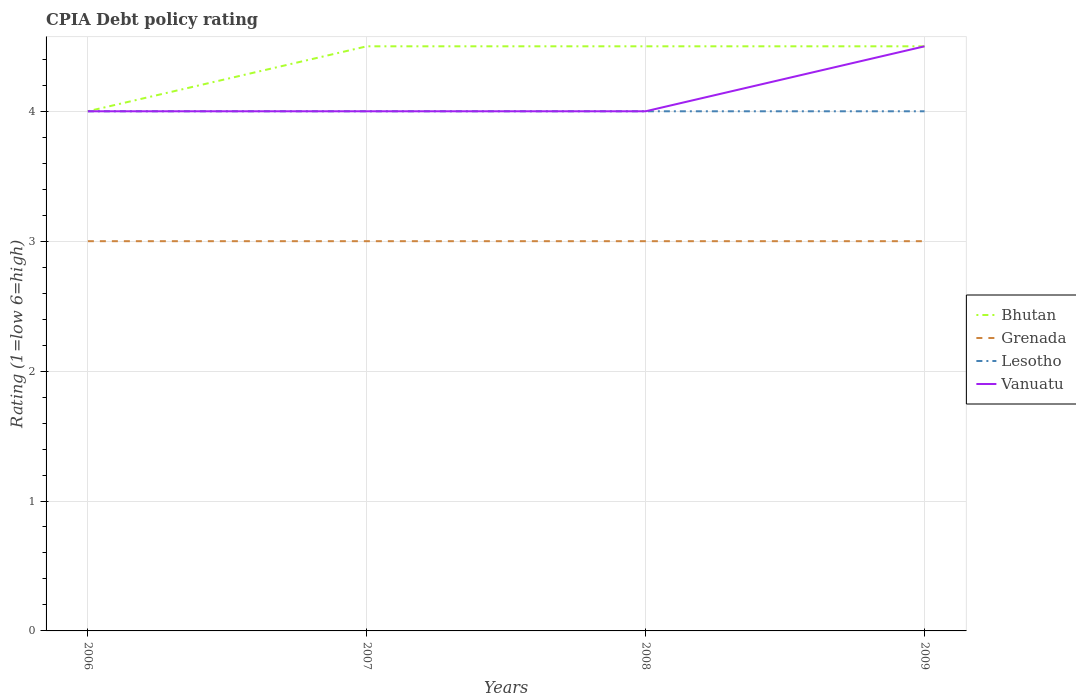How many different coloured lines are there?
Provide a short and direct response. 4. Across all years, what is the maximum CPIA rating in Lesotho?
Make the answer very short. 4. What is the total CPIA rating in Bhutan in the graph?
Your response must be concise. -0.5. What is the difference between the highest and the second highest CPIA rating in Lesotho?
Your response must be concise. 0. What is the difference between the highest and the lowest CPIA rating in Vanuatu?
Make the answer very short. 1. How many lines are there?
Provide a succinct answer. 4. How many years are there in the graph?
Give a very brief answer. 4. What is the difference between two consecutive major ticks on the Y-axis?
Your answer should be very brief. 1. Are the values on the major ticks of Y-axis written in scientific E-notation?
Your answer should be compact. No. Where does the legend appear in the graph?
Provide a succinct answer. Center right. How many legend labels are there?
Make the answer very short. 4. How are the legend labels stacked?
Make the answer very short. Vertical. What is the title of the graph?
Make the answer very short. CPIA Debt policy rating. Does "European Union" appear as one of the legend labels in the graph?
Your answer should be compact. No. What is the label or title of the Y-axis?
Offer a very short reply. Rating (1=low 6=high). What is the Rating (1=low 6=high) in Bhutan in 2006?
Your answer should be compact. 4. What is the Rating (1=low 6=high) of Grenada in 2007?
Ensure brevity in your answer.  3. What is the Rating (1=low 6=high) in Lesotho in 2007?
Give a very brief answer. 4. What is the Rating (1=low 6=high) in Vanuatu in 2007?
Offer a very short reply. 4. What is the Rating (1=low 6=high) of Bhutan in 2008?
Your answer should be compact. 4.5. What is the Rating (1=low 6=high) of Lesotho in 2008?
Your answer should be compact. 4. What is the Rating (1=low 6=high) in Vanuatu in 2008?
Ensure brevity in your answer.  4. What is the Rating (1=low 6=high) in Bhutan in 2009?
Offer a terse response. 4.5. What is the Rating (1=low 6=high) of Grenada in 2009?
Provide a succinct answer. 3. What is the Rating (1=low 6=high) of Lesotho in 2009?
Offer a very short reply. 4. What is the Rating (1=low 6=high) of Vanuatu in 2009?
Ensure brevity in your answer.  4.5. Across all years, what is the maximum Rating (1=low 6=high) of Lesotho?
Your answer should be very brief. 4. Across all years, what is the minimum Rating (1=low 6=high) in Bhutan?
Your response must be concise. 4. Across all years, what is the minimum Rating (1=low 6=high) of Grenada?
Your answer should be compact. 3. Across all years, what is the minimum Rating (1=low 6=high) in Vanuatu?
Your answer should be very brief. 4. What is the total Rating (1=low 6=high) of Bhutan in the graph?
Provide a short and direct response. 17.5. What is the total Rating (1=low 6=high) in Vanuatu in the graph?
Your answer should be compact. 16.5. What is the difference between the Rating (1=low 6=high) of Bhutan in 2006 and that in 2008?
Ensure brevity in your answer.  -0.5. What is the difference between the Rating (1=low 6=high) in Grenada in 2006 and that in 2008?
Make the answer very short. 0. What is the difference between the Rating (1=low 6=high) of Bhutan in 2006 and that in 2009?
Offer a very short reply. -0.5. What is the difference between the Rating (1=low 6=high) in Grenada in 2006 and that in 2009?
Give a very brief answer. 0. What is the difference between the Rating (1=low 6=high) in Vanuatu in 2006 and that in 2009?
Offer a terse response. -0.5. What is the difference between the Rating (1=low 6=high) in Bhutan in 2007 and that in 2008?
Offer a very short reply. 0. What is the difference between the Rating (1=low 6=high) of Grenada in 2007 and that in 2008?
Make the answer very short. 0. What is the difference between the Rating (1=low 6=high) of Lesotho in 2007 and that in 2008?
Your answer should be compact. 0. What is the difference between the Rating (1=low 6=high) in Grenada in 2008 and that in 2009?
Provide a short and direct response. 0. What is the difference between the Rating (1=low 6=high) of Lesotho in 2008 and that in 2009?
Provide a short and direct response. 0. What is the difference between the Rating (1=low 6=high) in Vanuatu in 2008 and that in 2009?
Your answer should be very brief. -0.5. What is the difference between the Rating (1=low 6=high) in Bhutan in 2006 and the Rating (1=low 6=high) in Grenada in 2007?
Provide a short and direct response. 1. What is the difference between the Rating (1=low 6=high) of Grenada in 2006 and the Rating (1=low 6=high) of Lesotho in 2007?
Provide a short and direct response. -1. What is the difference between the Rating (1=low 6=high) in Bhutan in 2006 and the Rating (1=low 6=high) in Lesotho in 2008?
Provide a short and direct response. 0. What is the difference between the Rating (1=low 6=high) in Bhutan in 2006 and the Rating (1=low 6=high) in Vanuatu in 2008?
Your answer should be very brief. 0. What is the difference between the Rating (1=low 6=high) in Grenada in 2006 and the Rating (1=low 6=high) in Lesotho in 2008?
Offer a terse response. -1. What is the difference between the Rating (1=low 6=high) in Grenada in 2006 and the Rating (1=low 6=high) in Vanuatu in 2008?
Your answer should be compact. -1. What is the difference between the Rating (1=low 6=high) in Lesotho in 2006 and the Rating (1=low 6=high) in Vanuatu in 2008?
Your response must be concise. 0. What is the difference between the Rating (1=low 6=high) of Bhutan in 2006 and the Rating (1=low 6=high) of Vanuatu in 2009?
Your answer should be very brief. -0.5. What is the difference between the Rating (1=low 6=high) in Grenada in 2006 and the Rating (1=low 6=high) in Vanuatu in 2009?
Your response must be concise. -1.5. What is the difference between the Rating (1=low 6=high) in Lesotho in 2006 and the Rating (1=low 6=high) in Vanuatu in 2009?
Offer a terse response. -0.5. What is the difference between the Rating (1=low 6=high) in Bhutan in 2007 and the Rating (1=low 6=high) in Lesotho in 2008?
Provide a short and direct response. 0.5. What is the difference between the Rating (1=low 6=high) of Grenada in 2007 and the Rating (1=low 6=high) of Vanuatu in 2008?
Give a very brief answer. -1. What is the difference between the Rating (1=low 6=high) in Lesotho in 2007 and the Rating (1=low 6=high) in Vanuatu in 2008?
Give a very brief answer. 0. What is the difference between the Rating (1=low 6=high) of Bhutan in 2007 and the Rating (1=low 6=high) of Grenada in 2009?
Provide a succinct answer. 1.5. What is the difference between the Rating (1=low 6=high) in Bhutan in 2007 and the Rating (1=low 6=high) in Vanuatu in 2009?
Offer a terse response. 0. What is the difference between the Rating (1=low 6=high) in Grenada in 2007 and the Rating (1=low 6=high) in Lesotho in 2009?
Your answer should be compact. -1. What is the difference between the Rating (1=low 6=high) of Grenada in 2007 and the Rating (1=low 6=high) of Vanuatu in 2009?
Keep it short and to the point. -1.5. What is the difference between the Rating (1=low 6=high) in Bhutan in 2008 and the Rating (1=low 6=high) in Lesotho in 2009?
Ensure brevity in your answer.  0.5. What is the difference between the Rating (1=low 6=high) of Bhutan in 2008 and the Rating (1=low 6=high) of Vanuatu in 2009?
Offer a terse response. 0. What is the average Rating (1=low 6=high) in Bhutan per year?
Offer a very short reply. 4.38. What is the average Rating (1=low 6=high) in Vanuatu per year?
Your answer should be very brief. 4.12. In the year 2006, what is the difference between the Rating (1=low 6=high) of Bhutan and Rating (1=low 6=high) of Grenada?
Your response must be concise. 1. In the year 2006, what is the difference between the Rating (1=low 6=high) in Bhutan and Rating (1=low 6=high) in Vanuatu?
Your answer should be compact. 0. In the year 2006, what is the difference between the Rating (1=low 6=high) in Lesotho and Rating (1=low 6=high) in Vanuatu?
Offer a terse response. 0. In the year 2007, what is the difference between the Rating (1=low 6=high) of Bhutan and Rating (1=low 6=high) of Grenada?
Ensure brevity in your answer.  1.5. In the year 2007, what is the difference between the Rating (1=low 6=high) in Bhutan and Rating (1=low 6=high) in Lesotho?
Ensure brevity in your answer.  0.5. In the year 2007, what is the difference between the Rating (1=low 6=high) of Grenada and Rating (1=low 6=high) of Lesotho?
Offer a very short reply. -1. In the year 2007, what is the difference between the Rating (1=low 6=high) of Grenada and Rating (1=low 6=high) of Vanuatu?
Give a very brief answer. -1. In the year 2008, what is the difference between the Rating (1=low 6=high) in Bhutan and Rating (1=low 6=high) in Lesotho?
Your response must be concise. 0.5. In the year 2008, what is the difference between the Rating (1=low 6=high) in Bhutan and Rating (1=low 6=high) in Vanuatu?
Ensure brevity in your answer.  0.5. In the year 2008, what is the difference between the Rating (1=low 6=high) in Grenada and Rating (1=low 6=high) in Lesotho?
Offer a very short reply. -1. In the year 2008, what is the difference between the Rating (1=low 6=high) in Grenada and Rating (1=low 6=high) in Vanuatu?
Your response must be concise. -1. In the year 2009, what is the difference between the Rating (1=low 6=high) of Bhutan and Rating (1=low 6=high) of Lesotho?
Your answer should be very brief. 0.5. In the year 2009, what is the difference between the Rating (1=low 6=high) of Bhutan and Rating (1=low 6=high) of Vanuatu?
Your response must be concise. 0. In the year 2009, what is the difference between the Rating (1=low 6=high) of Grenada and Rating (1=low 6=high) of Vanuatu?
Keep it short and to the point. -1.5. What is the ratio of the Rating (1=low 6=high) of Bhutan in 2006 to that in 2007?
Make the answer very short. 0.89. What is the ratio of the Rating (1=low 6=high) of Grenada in 2006 to that in 2007?
Ensure brevity in your answer.  1. What is the ratio of the Rating (1=low 6=high) in Lesotho in 2006 to that in 2007?
Provide a succinct answer. 1. What is the ratio of the Rating (1=low 6=high) in Bhutan in 2006 to that in 2008?
Provide a succinct answer. 0.89. What is the ratio of the Rating (1=low 6=high) of Lesotho in 2006 to that in 2008?
Give a very brief answer. 1. What is the ratio of the Rating (1=low 6=high) of Bhutan in 2006 to that in 2009?
Your answer should be compact. 0.89. What is the ratio of the Rating (1=low 6=high) of Grenada in 2006 to that in 2009?
Give a very brief answer. 1. What is the ratio of the Rating (1=low 6=high) of Vanuatu in 2006 to that in 2009?
Make the answer very short. 0.89. What is the ratio of the Rating (1=low 6=high) in Bhutan in 2007 to that in 2008?
Make the answer very short. 1. What is the ratio of the Rating (1=low 6=high) in Grenada in 2007 to that in 2008?
Make the answer very short. 1. What is the ratio of the Rating (1=low 6=high) of Lesotho in 2007 to that in 2008?
Make the answer very short. 1. What is the ratio of the Rating (1=low 6=high) in Grenada in 2007 to that in 2009?
Give a very brief answer. 1. What is the ratio of the Rating (1=low 6=high) of Bhutan in 2008 to that in 2009?
Your response must be concise. 1. What is the ratio of the Rating (1=low 6=high) in Lesotho in 2008 to that in 2009?
Keep it short and to the point. 1. What is the difference between the highest and the second highest Rating (1=low 6=high) of Lesotho?
Your response must be concise. 0. What is the difference between the highest and the lowest Rating (1=low 6=high) of Grenada?
Provide a succinct answer. 0. What is the difference between the highest and the lowest Rating (1=low 6=high) in Vanuatu?
Your answer should be very brief. 0.5. 